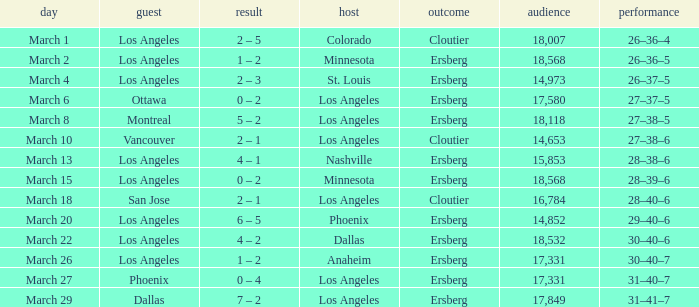On the Date of March 13, who was the Home team? Nashville. 